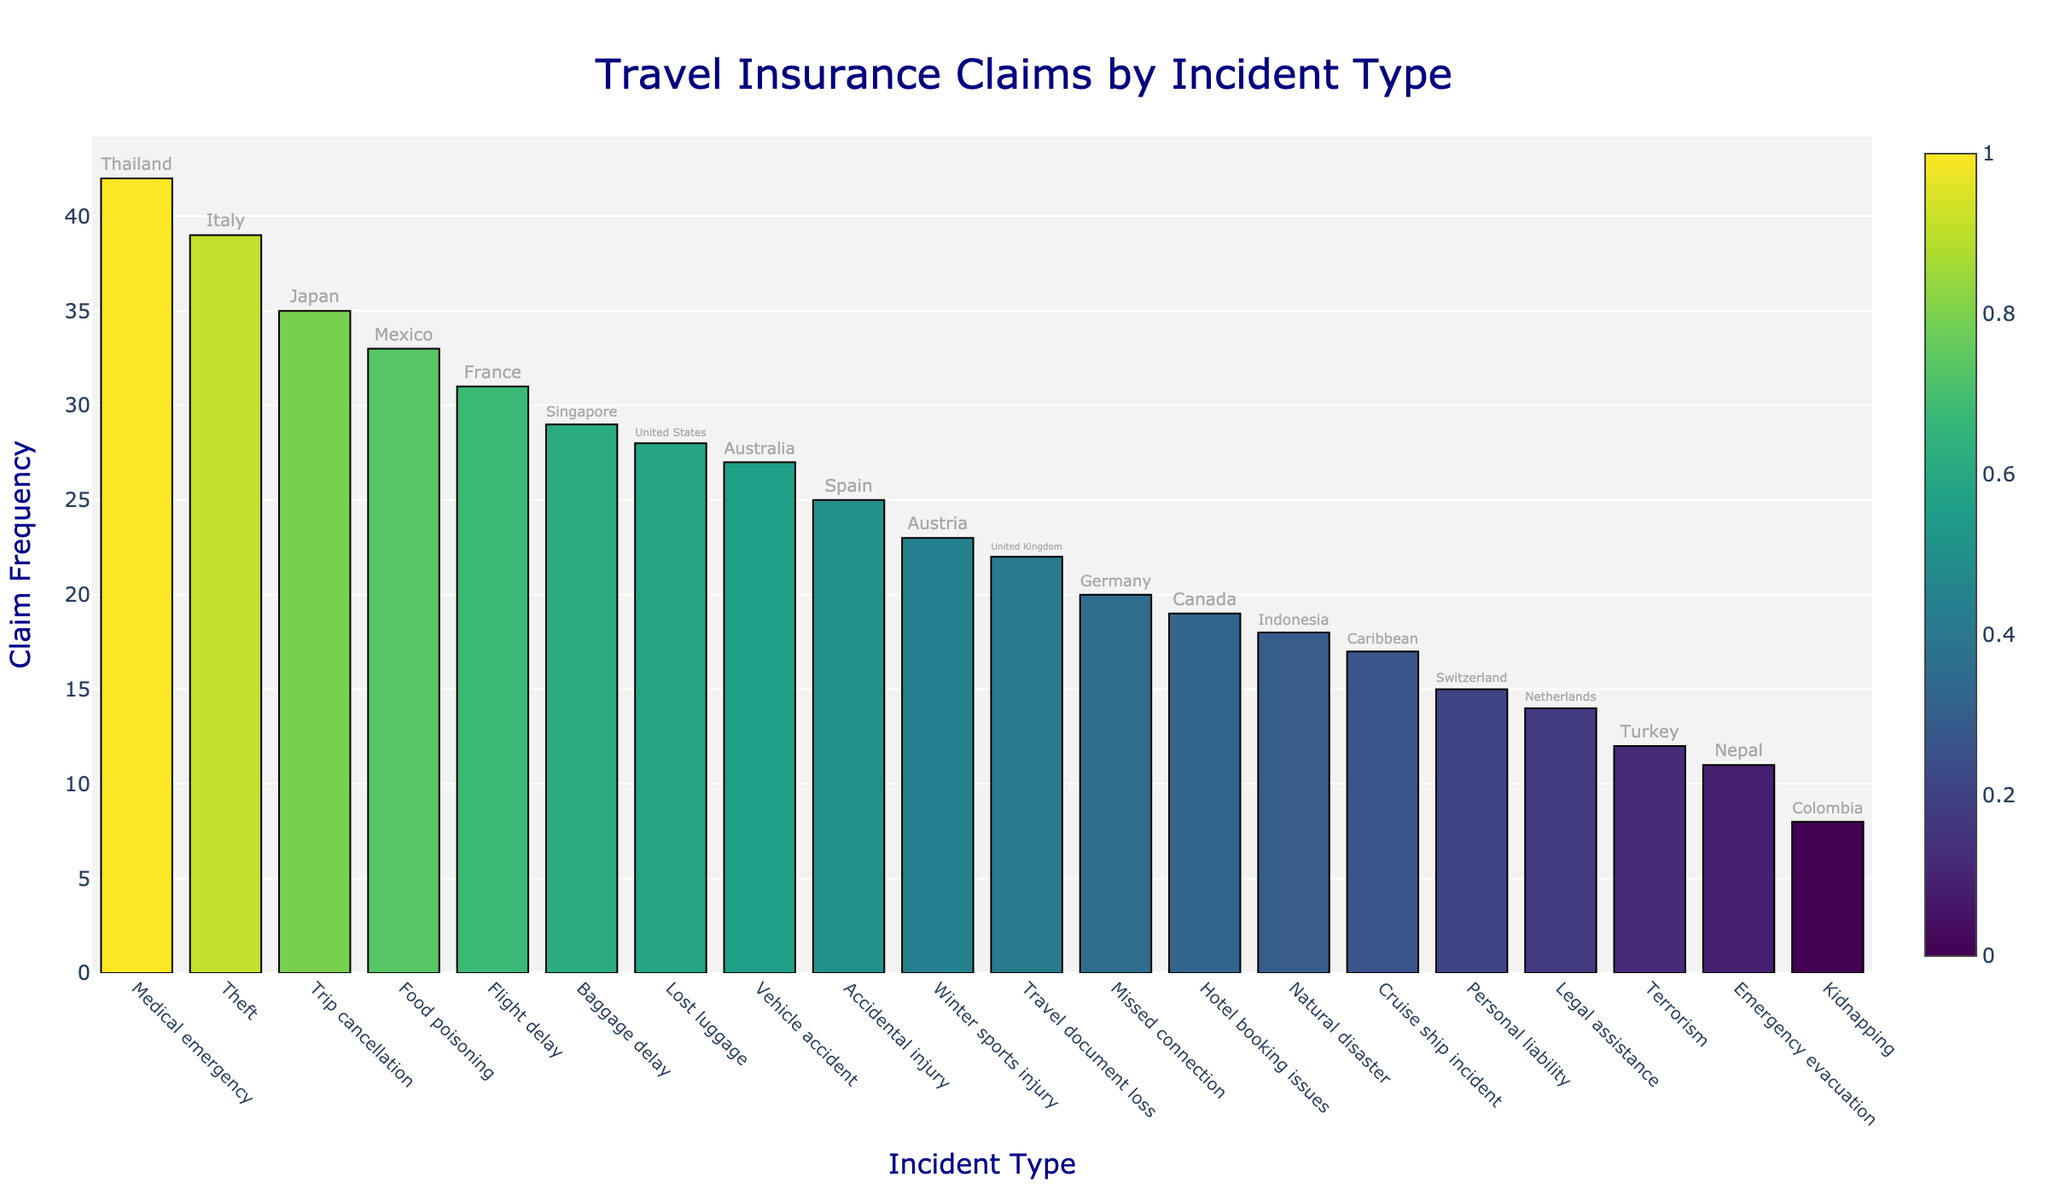What's the title of the plot? The title is typically displayed prominently at the top of the figure. Here, it reads "Travel Insurance Claims by Incident Type".
Answer: Travel Insurance Claims by Incident Type Which incident type has the highest claim frequency? By examining the height of the bars, the incident type with the tallest bar represents the highest claim frequency. In this plot, the highest bar corresponds to "Medical emergency".
Answer: Medical emergency What's the total claim frequency for incidents occurring in European countries? Add the claim frequencies of incidents for European countries listed: Lost luggage (28) in the United States is not in Europe, so count: France (31), Italy (39), Spain (25), United Kingdom (22), Germany (20), Switzerland (15), Austria (23), Netherlands (14). The sum is 189.
Answer: 189 How does the claim frequency for "Natural disaster" compare to "Food poisoning"? Look at the bars for both "Natural disaster" and "Food poisoning". The "Food poisoning" bar is taller than the "Natural disaster" bar. Specifically, Food poisoning has a frequency of 33, while Natural disaster has a frequency of 18.
Answer: Food poisoning is more frequent than Natural disaster Is the claim frequency for "Baggage delay" closer to that for "Flight delay" or "Winter sports injury"? Compare the claim frequencies of "Baggage delay" (29), "Flight delay" (31), and "Winter sports injury" (23). The value 29 is closer to 31 (Flight delay) than 23 (Winter sports injury).
Answer: Flight delay Which location is associated with "Terrorism" and how frequent are the claims? Find the bar labeled "Terrorism" and look at the text displayed above or beside it. It indicates "Turkey" as the location with a claim frequency of 12.
Answer: Turkey with a frequency of 12 Which incident type has the lowest claim frequency and where did it occur? The shortest bar in the plot indicates the lowest claim frequency. Here, it corresponds to "Kidnapping" in Colombia.
Answer: Kidnapping in Colombia What is the median claim frequency of all incident types? List all claim frequencies in ascending order: 8, 11, 12, 14, 15, 17, 18, 19, 20, 22, 23, 25, 27, 28, 29, 31, 33, 35, 39, 42. The median is the middle value of these sorted claim frequencies, which is (22 + 23)/2 = 22.5.
Answer: 22.5 Which country appears with a claim related to "Emergency evacuation"? By examining the bar labeled "Emergency evacuation", the text above indicates it is associated with Nepal.
Answer: Nepal 